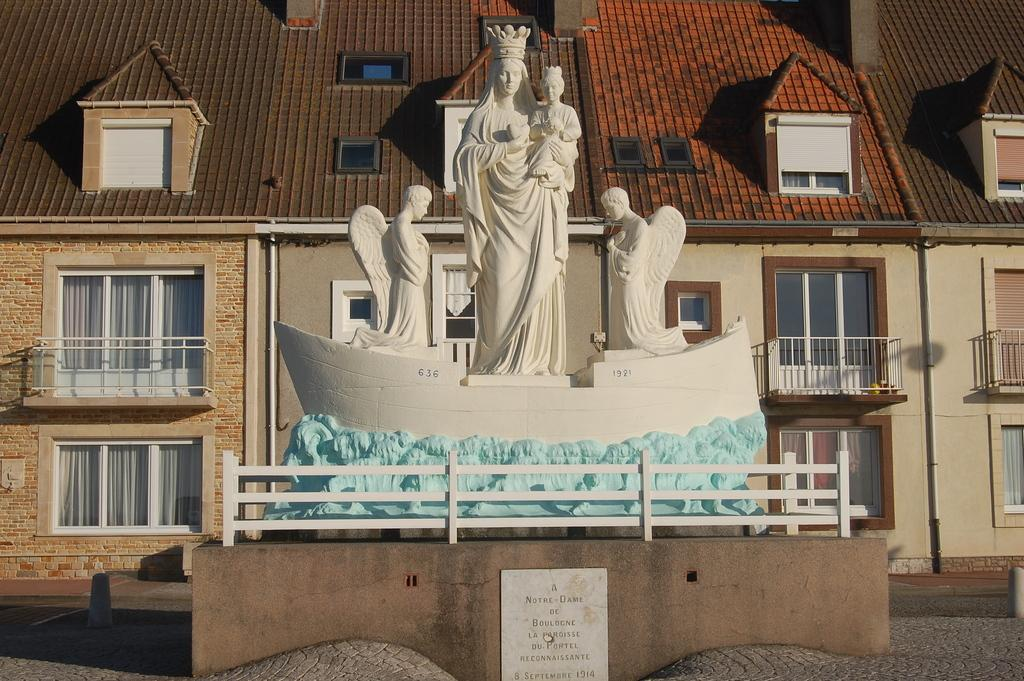What can be seen on the path in the image? There are statues on a path in the image. What is located behind the statues? There is a building with windows behind the statues. What note is the statue playing on the path in the image? There are no musical instruments or notes present in the image; the statues are stationary and not playing any music. 